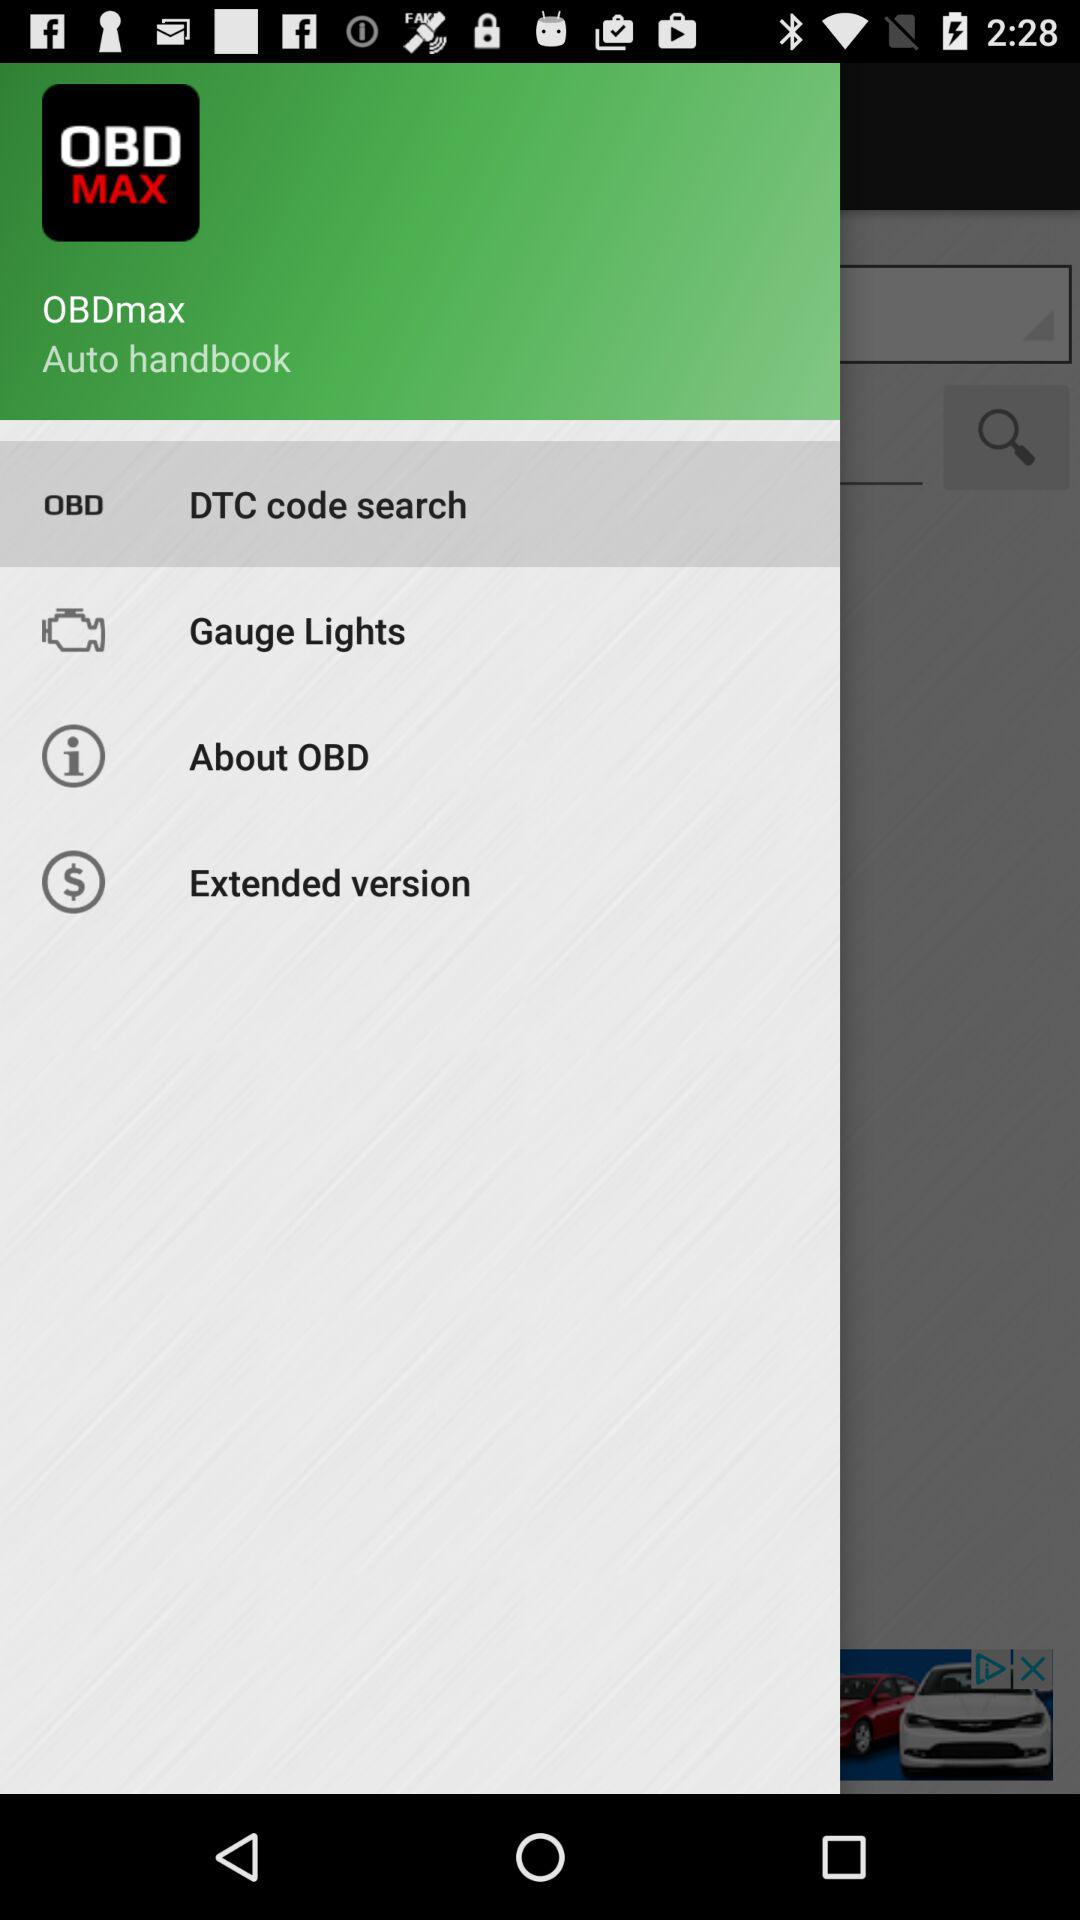What is the application name? The application name is "OBDmax". 